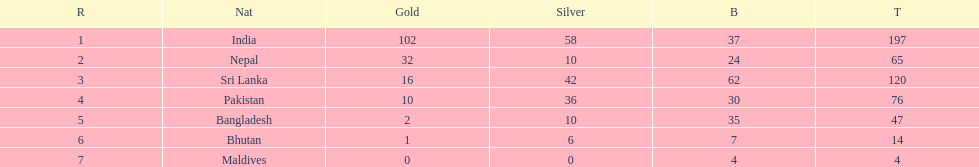How many gold medals were awarded between all 7 nations? 163. 